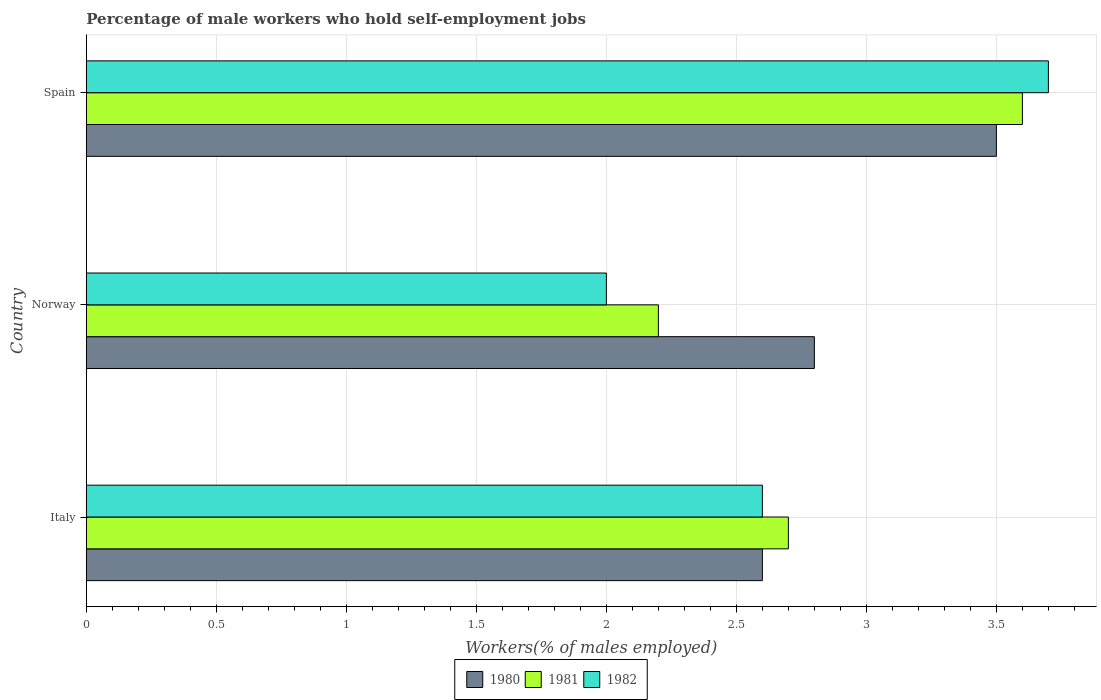How many different coloured bars are there?
Keep it short and to the point. 3. Are the number of bars per tick equal to the number of legend labels?
Your answer should be compact. Yes. How many bars are there on the 1st tick from the top?
Offer a terse response. 3. What is the label of the 3rd group of bars from the top?
Ensure brevity in your answer.  Italy. What is the percentage of self-employed male workers in 1981 in Italy?
Provide a succinct answer. 2.7. Across all countries, what is the maximum percentage of self-employed male workers in 1982?
Give a very brief answer. 3.7. Across all countries, what is the minimum percentage of self-employed male workers in 1980?
Ensure brevity in your answer.  2.6. What is the total percentage of self-employed male workers in 1981 in the graph?
Your response must be concise. 8.5. What is the difference between the percentage of self-employed male workers in 1981 in Italy and that in Norway?
Your response must be concise. 0.5. What is the difference between the percentage of self-employed male workers in 1982 in Spain and the percentage of self-employed male workers in 1980 in Norway?
Make the answer very short. 0.9. What is the average percentage of self-employed male workers in 1980 per country?
Your response must be concise. 2.97. What is the difference between the percentage of self-employed male workers in 1980 and percentage of self-employed male workers in 1981 in Italy?
Ensure brevity in your answer.  -0.1. What is the ratio of the percentage of self-employed male workers in 1980 in Norway to that in Spain?
Provide a succinct answer. 0.8. Is the percentage of self-employed male workers in 1980 in Italy less than that in Norway?
Keep it short and to the point. Yes. Is the difference between the percentage of self-employed male workers in 1980 in Norway and Spain greater than the difference between the percentage of self-employed male workers in 1981 in Norway and Spain?
Offer a very short reply. Yes. What is the difference between the highest and the second highest percentage of self-employed male workers in 1982?
Keep it short and to the point. 1.1. What is the difference between the highest and the lowest percentage of self-employed male workers in 1981?
Offer a very short reply. 1.4. In how many countries, is the percentage of self-employed male workers in 1982 greater than the average percentage of self-employed male workers in 1982 taken over all countries?
Provide a short and direct response. 1. Is it the case that in every country, the sum of the percentage of self-employed male workers in 1980 and percentage of self-employed male workers in 1982 is greater than the percentage of self-employed male workers in 1981?
Offer a terse response. Yes. What is the difference between two consecutive major ticks on the X-axis?
Make the answer very short. 0.5. Are the values on the major ticks of X-axis written in scientific E-notation?
Your answer should be compact. No. Does the graph contain any zero values?
Make the answer very short. No. Does the graph contain grids?
Your answer should be compact. Yes. How many legend labels are there?
Keep it short and to the point. 3. What is the title of the graph?
Provide a short and direct response. Percentage of male workers who hold self-employment jobs. Does "1967" appear as one of the legend labels in the graph?
Make the answer very short. No. What is the label or title of the X-axis?
Give a very brief answer. Workers(% of males employed). What is the label or title of the Y-axis?
Offer a very short reply. Country. What is the Workers(% of males employed) of 1980 in Italy?
Keep it short and to the point. 2.6. What is the Workers(% of males employed) in 1981 in Italy?
Provide a succinct answer. 2.7. What is the Workers(% of males employed) in 1982 in Italy?
Your answer should be very brief. 2.6. What is the Workers(% of males employed) of 1980 in Norway?
Ensure brevity in your answer.  2.8. What is the Workers(% of males employed) in 1981 in Norway?
Give a very brief answer. 2.2. What is the Workers(% of males employed) in 1980 in Spain?
Provide a succinct answer. 3.5. What is the Workers(% of males employed) of 1981 in Spain?
Keep it short and to the point. 3.6. What is the Workers(% of males employed) of 1982 in Spain?
Ensure brevity in your answer.  3.7. Across all countries, what is the maximum Workers(% of males employed) in 1981?
Provide a short and direct response. 3.6. Across all countries, what is the maximum Workers(% of males employed) in 1982?
Provide a short and direct response. 3.7. Across all countries, what is the minimum Workers(% of males employed) of 1980?
Give a very brief answer. 2.6. Across all countries, what is the minimum Workers(% of males employed) of 1981?
Your answer should be compact. 2.2. Across all countries, what is the minimum Workers(% of males employed) in 1982?
Provide a succinct answer. 2. What is the total Workers(% of males employed) in 1980 in the graph?
Offer a very short reply. 8.9. What is the total Workers(% of males employed) in 1982 in the graph?
Provide a short and direct response. 8.3. What is the difference between the Workers(% of males employed) in 1980 in Italy and that in Norway?
Offer a terse response. -0.2. What is the difference between the Workers(% of males employed) in 1981 in Italy and that in Norway?
Offer a very short reply. 0.5. What is the difference between the Workers(% of males employed) of 1982 in Italy and that in Spain?
Make the answer very short. -1.1. What is the difference between the Workers(% of males employed) of 1981 in Norway and that in Spain?
Your response must be concise. -1.4. What is the difference between the Workers(% of males employed) of 1980 in Italy and the Workers(% of males employed) of 1982 in Spain?
Give a very brief answer. -1.1. What is the difference between the Workers(% of males employed) in 1980 in Norway and the Workers(% of males employed) in 1981 in Spain?
Your answer should be compact. -0.8. What is the difference between the Workers(% of males employed) in 1981 in Norway and the Workers(% of males employed) in 1982 in Spain?
Give a very brief answer. -1.5. What is the average Workers(% of males employed) in 1980 per country?
Offer a very short reply. 2.97. What is the average Workers(% of males employed) of 1981 per country?
Your response must be concise. 2.83. What is the average Workers(% of males employed) in 1982 per country?
Keep it short and to the point. 2.77. What is the difference between the Workers(% of males employed) of 1980 and Workers(% of males employed) of 1982 in Italy?
Ensure brevity in your answer.  0. What is the difference between the Workers(% of males employed) of 1980 and Workers(% of males employed) of 1981 in Norway?
Ensure brevity in your answer.  0.6. What is the difference between the Workers(% of males employed) of 1981 and Workers(% of males employed) of 1982 in Spain?
Your answer should be compact. -0.1. What is the ratio of the Workers(% of males employed) of 1981 in Italy to that in Norway?
Your answer should be very brief. 1.23. What is the ratio of the Workers(% of males employed) of 1980 in Italy to that in Spain?
Give a very brief answer. 0.74. What is the ratio of the Workers(% of males employed) in 1982 in Italy to that in Spain?
Your response must be concise. 0.7. What is the ratio of the Workers(% of males employed) of 1981 in Norway to that in Spain?
Offer a terse response. 0.61. What is the ratio of the Workers(% of males employed) in 1982 in Norway to that in Spain?
Ensure brevity in your answer.  0.54. What is the difference between the highest and the second highest Workers(% of males employed) in 1982?
Keep it short and to the point. 1.1. What is the difference between the highest and the lowest Workers(% of males employed) in 1981?
Make the answer very short. 1.4. What is the difference between the highest and the lowest Workers(% of males employed) of 1982?
Provide a succinct answer. 1.7. 